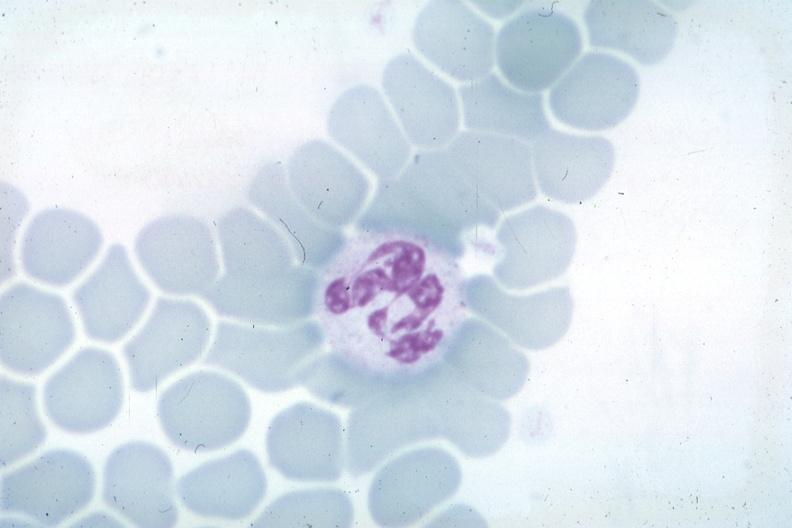s hemangioma present?
Answer the question using a single word or phrase. No 